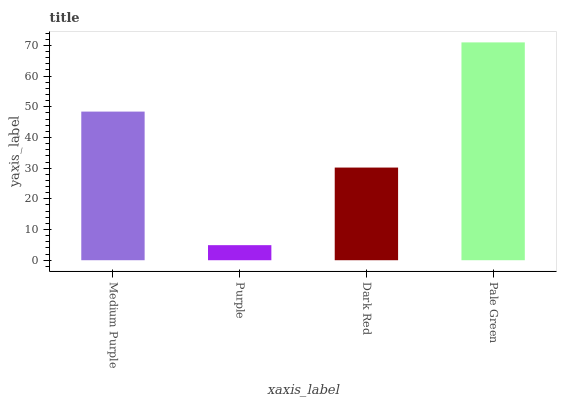Is Purple the minimum?
Answer yes or no. Yes. Is Pale Green the maximum?
Answer yes or no. Yes. Is Dark Red the minimum?
Answer yes or no. No. Is Dark Red the maximum?
Answer yes or no. No. Is Dark Red greater than Purple?
Answer yes or no. Yes. Is Purple less than Dark Red?
Answer yes or no. Yes. Is Purple greater than Dark Red?
Answer yes or no. No. Is Dark Red less than Purple?
Answer yes or no. No. Is Medium Purple the high median?
Answer yes or no. Yes. Is Dark Red the low median?
Answer yes or no. Yes. Is Pale Green the high median?
Answer yes or no. No. Is Pale Green the low median?
Answer yes or no. No. 